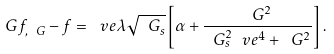<formula> <loc_0><loc_0><loc_500><loc_500>\ G f _ { , \ G } - f = \ v e \lambda \sqrt { \ G _ { s } } \left [ \alpha + \frac { \ G ^ { 2 } } { \ G _ { s } ^ { 2 } \ v e ^ { 4 } + \ G ^ { 2 } } \right ] \, .</formula> 